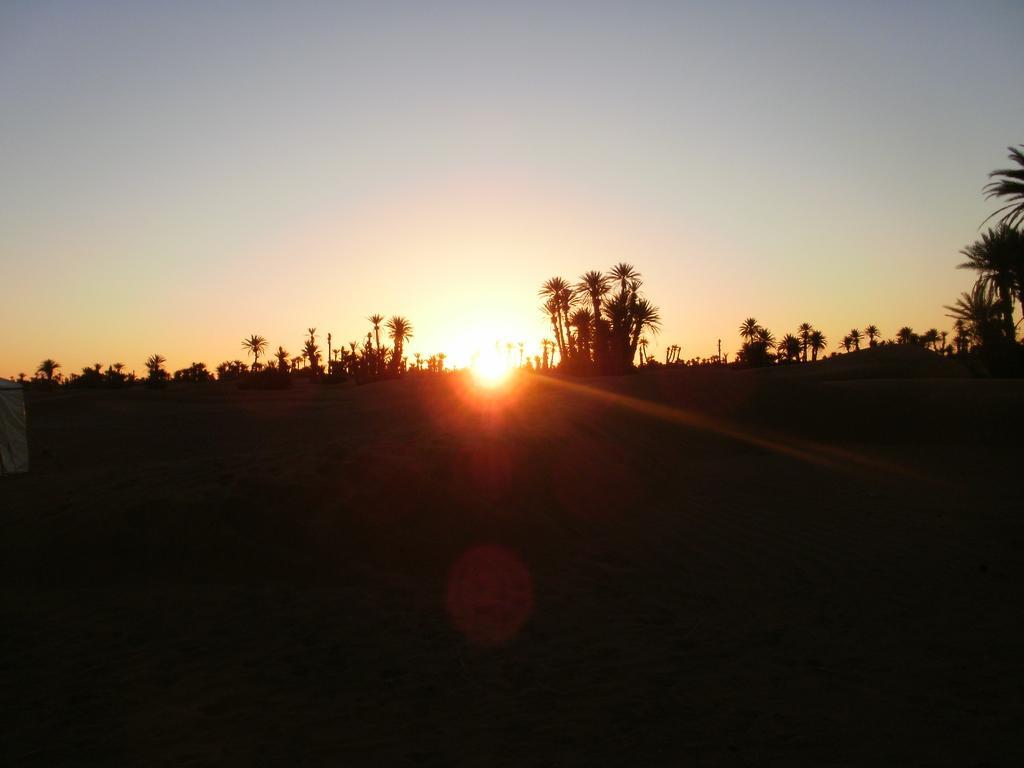Describe this image in one or two sentences. In this picture we can see ground. In the background of the image we can see trees and sky. 